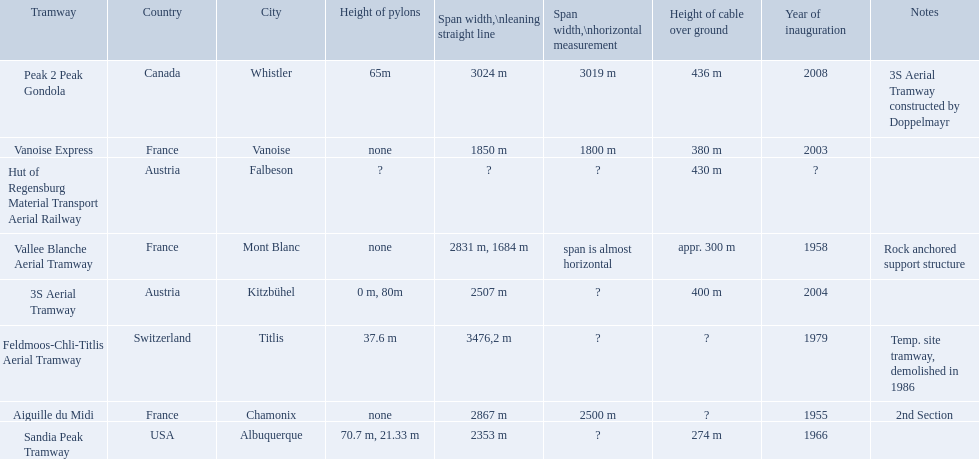When was the aiguille du midi tramway inaugurated? 1955. When was the 3s aerial tramway inaugurated? 2004. Which one was inaugurated first? Aiguille du Midi. 